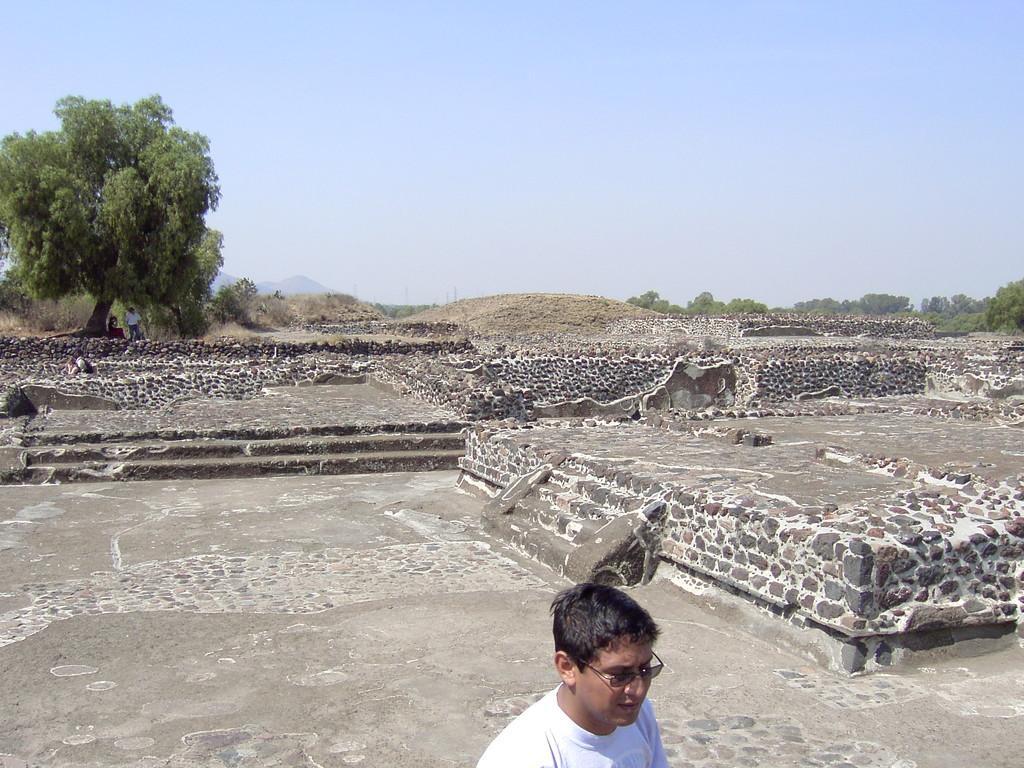In one or two sentences, can you explain what this image depicts? As we can see in the image in the front there is a person wearing white color t shirt. In the background there are trees. At the top there is sky. 